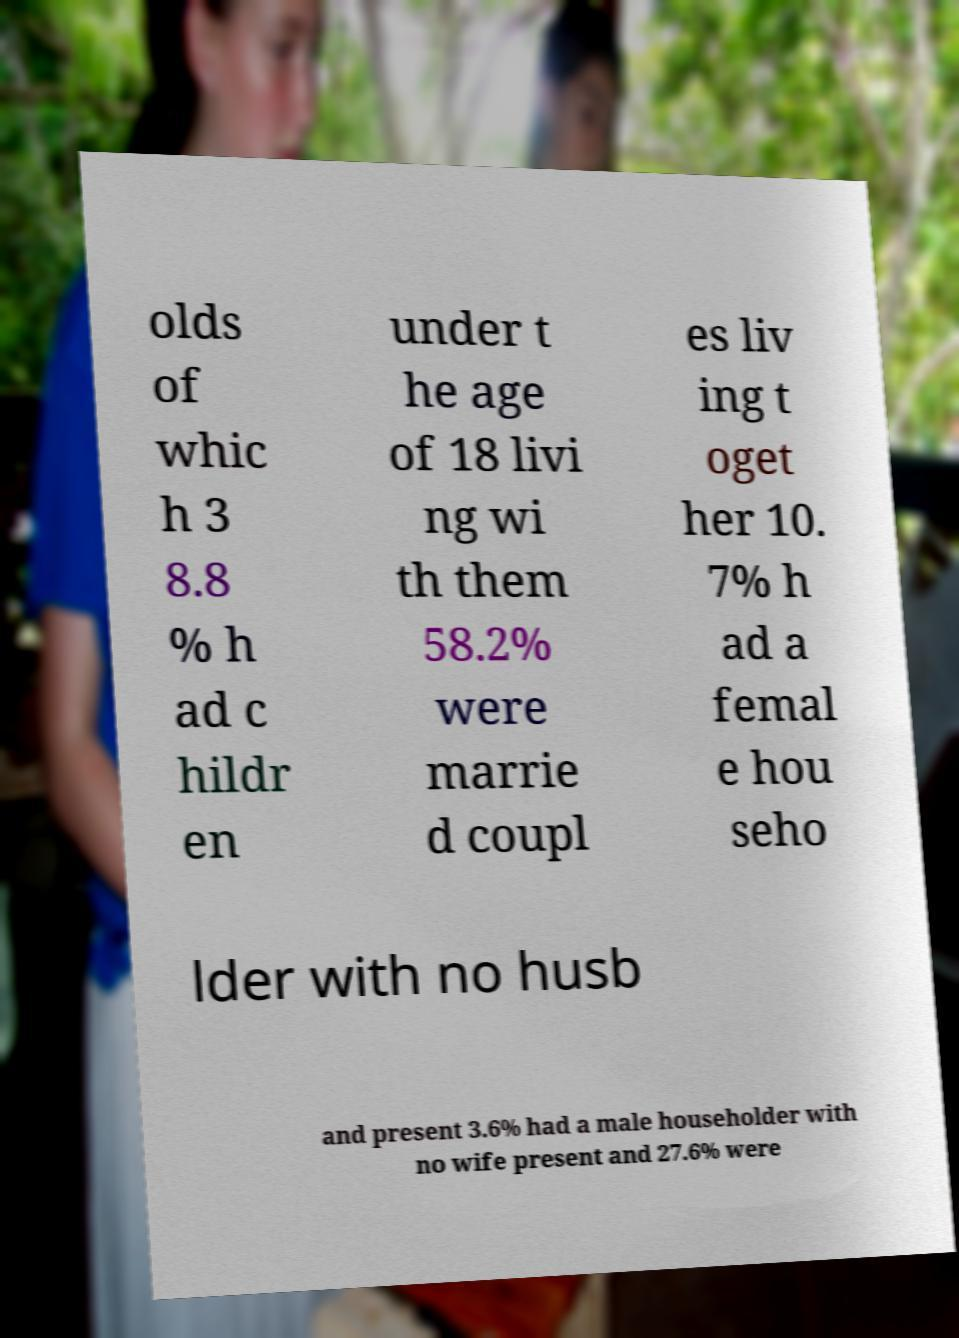For documentation purposes, I need the text within this image transcribed. Could you provide that? olds of whic h 3 8.8 % h ad c hildr en under t he age of 18 livi ng wi th them 58.2% were marrie d coupl es liv ing t oget her 10. 7% h ad a femal e hou seho lder with no husb and present 3.6% had a male householder with no wife present and 27.6% were 